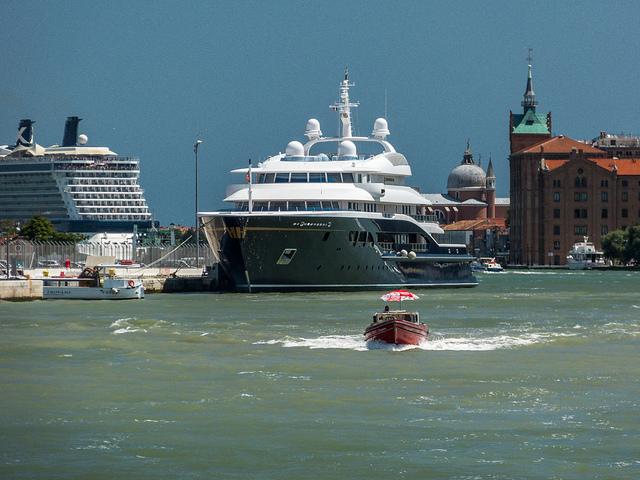What type of transportation is this?
Concise answer only. Boat. How many water vessels do you?
Keep it brief. 5. What is the color of water?
Concise answer only. Green. 